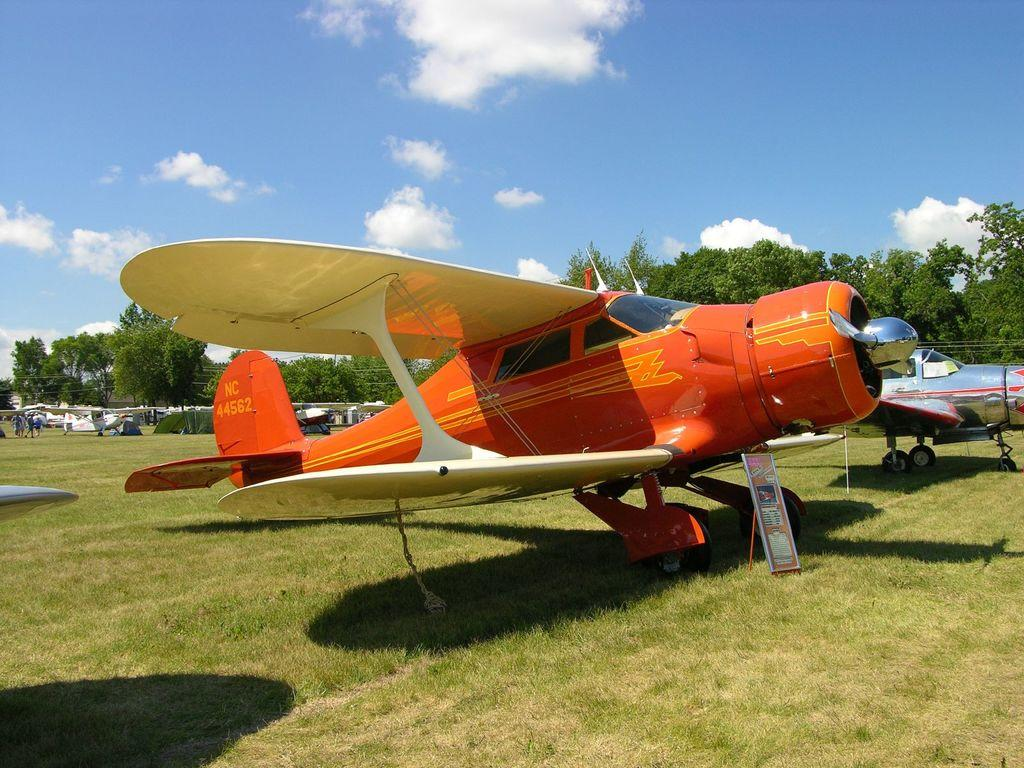What is the main subject of the image? The main subject of the image is aircraft. Where are the aircraft located? The aircraft are on a grassland. What can be seen in the background of the image? There are trees and the sky visible in the background of the image. How many dogs are present in the image? There are no dogs present in the image; it features aircraft on a grassland with trees and the sky in the background. 